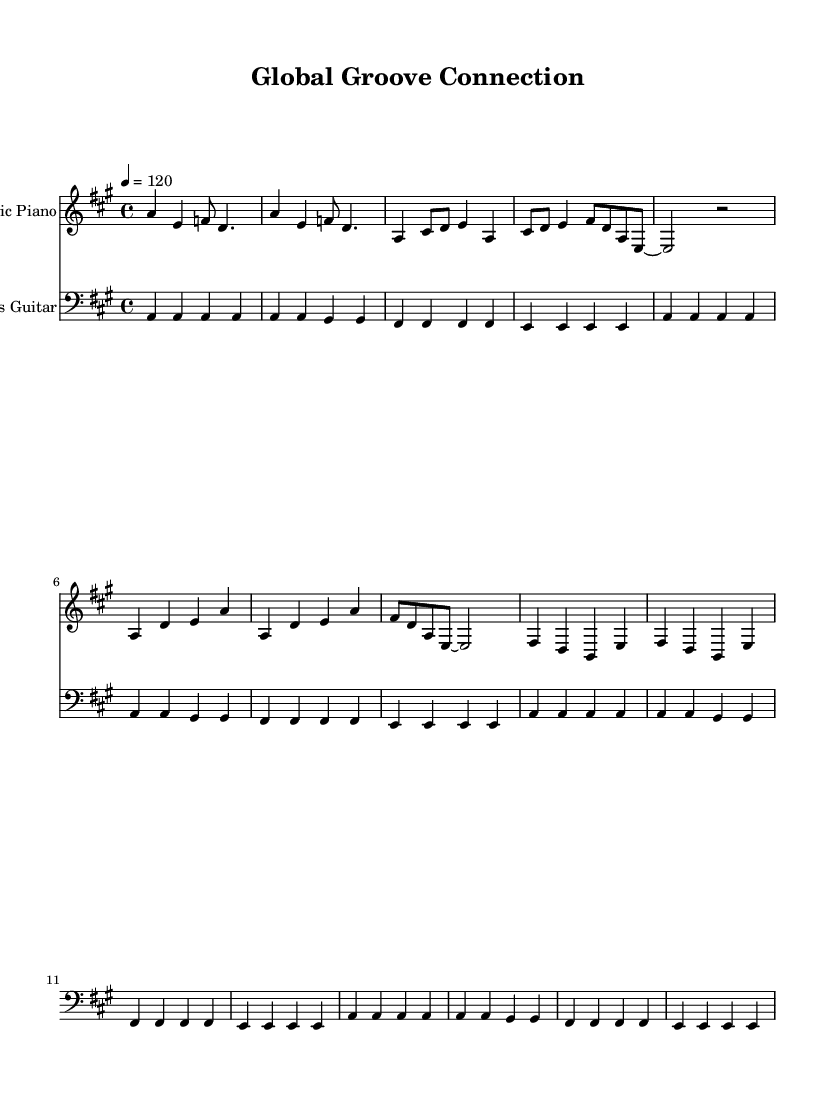What is the key signature of this music? The key signature is A major, which has three sharps (F#, C#, and G#). You can identify the key signature at the beginning of the staff, just after the clef symbol.
Answer: A major What is the time signature of this music? The time signature is 4/4, which indicates that there are four beats in each measure and the quarter note gets one beat. It can be found at the beginning of the music, indicated by the '4/4' notation.
Answer: 4/4 What is the tempo marking given in this sheet music? The tempo marking is a quarter note equaling 120 beats per minute, found in the tempo directive at the start of the music, which will guide the speed of the performance.
Answer: 120 How many measures are present in the main sections of the music? Counting the measures in both the verse and chorus, the verse contains 4 measures and the chorus contains 8 measures, giving a total of 12 measures in the main sections. A careful count of the measures in each section provides this total.
Answer: 12 Which instrument is indicated to play the upper part? The upper part is dedicated to the Electric Piano, as specified by the staff naming at the beginning of the corresponding staff.
Answer: Electric Piano Does the bass guitar part use any rests? No, the bass guitar part does not incorporate any rests; it is comprised entirely of sustained notes. This can be confirmed by examining the bass staff section, which shows continuous note values without breaks.
Answer: No 